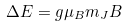Convert formula to latex. <formula><loc_0><loc_0><loc_500><loc_500>\Delta E = g \mu _ { B } m _ { J } B</formula> 